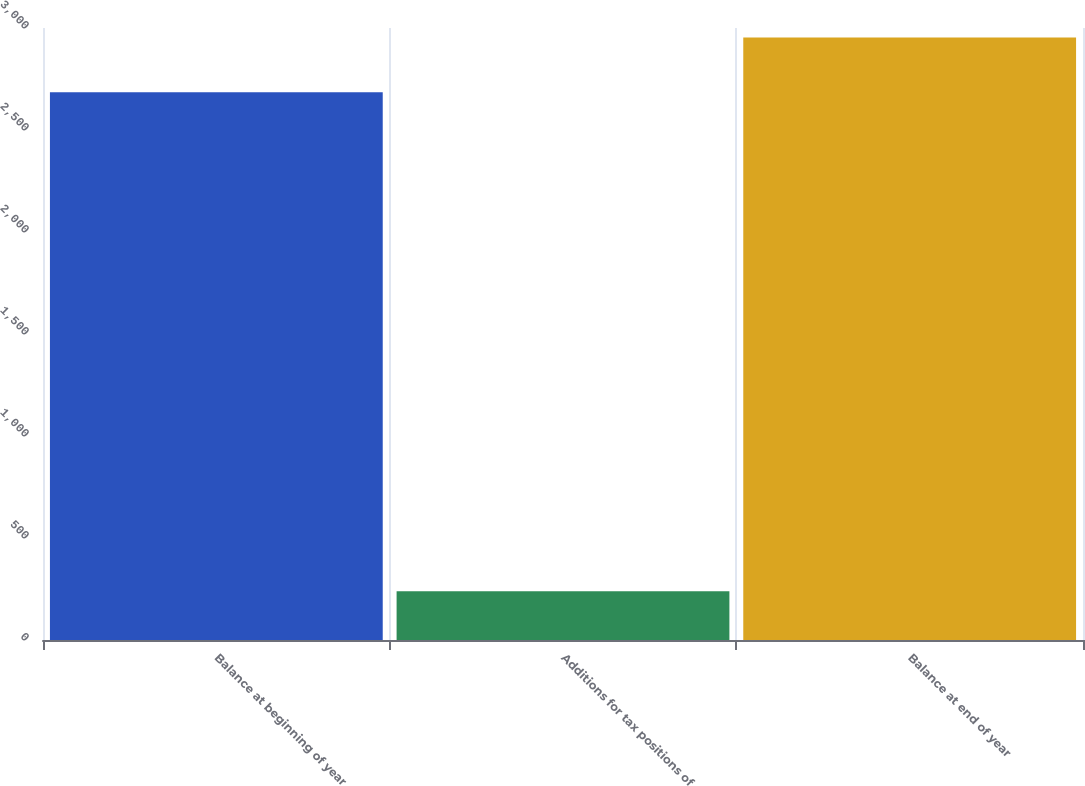Convert chart. <chart><loc_0><loc_0><loc_500><loc_500><bar_chart><fcel>Balance at beginning of year<fcel>Additions for tax positions of<fcel>Balance at end of year<nl><fcel>2685<fcel>239<fcel>2953.5<nl></chart> 